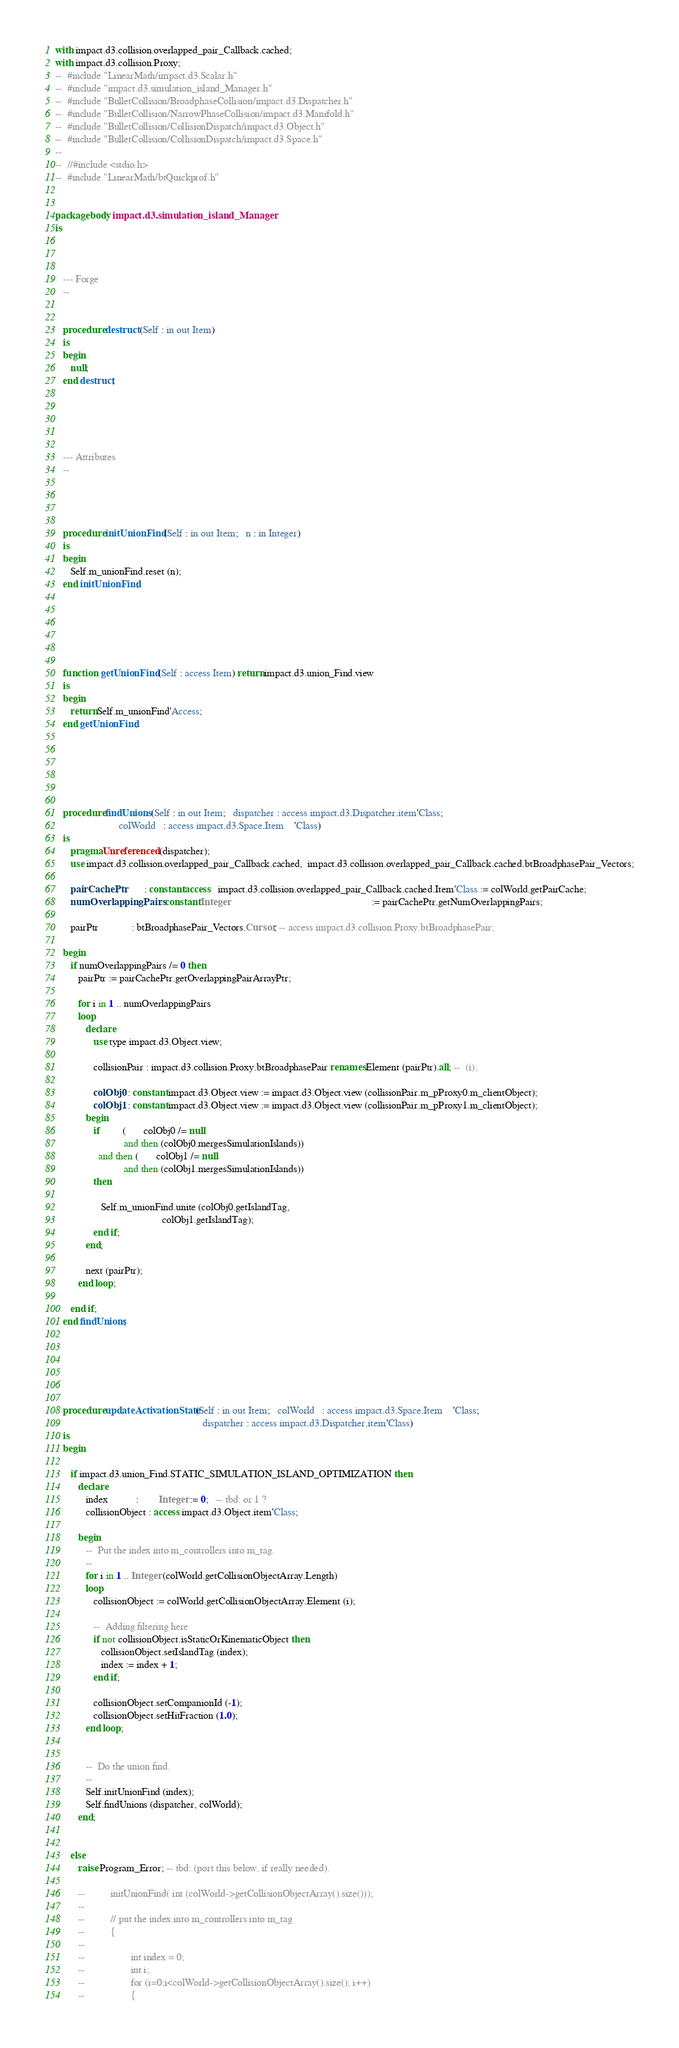Convert code to text. <code><loc_0><loc_0><loc_500><loc_500><_Ada_>with impact.d3.collision.overlapped_pair_Callback.cached;
with impact.d3.collision.Proxy;
--  #include "LinearMath/impact.d3.Scalar.h"
--  #include "impact.d3.simulation_island_Manager.h"
--  #include "BulletCollision/BroadphaseCollision/impact.d3.Dispatcher.h"
--  #include "BulletCollision/NarrowPhaseCollision/impact.d3.Manifold.h"
--  #include "BulletCollision/CollisionDispatch/impact.d3.Object.h"
--  #include "BulletCollision/CollisionDispatch/impact.d3.Space.h"
--
--  //#include <stdio.h>
--  #include "LinearMath/btQuickprof.h"


package body impact.d3.simulation_island_Manager
is



   --- Forge
   --


   procedure destruct (Self : in out Item)
   is
   begin
      null;
   end destruct;





   --- Attributes
   --




   procedure initUnionFind (Self : in out Item;   n : in Integer)
   is
   begin
      Self.m_unionFind.reset (n);
   end initUnionFind;






   function  getUnionFind (Self : access Item) return impact.d3.union_Find.view
   is
   begin
      return Self.m_unionFind'Access;
   end getUnionFind;






   procedure findUnions (Self : in out Item;   dispatcher : access impact.d3.Dispatcher.item'Class;
                         colWorld   : access impact.d3.Space.Item    'Class)
   is
      pragma Unreferenced (dispatcher);
      use impact.d3.collision.overlapped_pair_Callback.cached,  impact.d3.collision.overlapped_pair_Callback.cached.btBroadphasePair_Vectors;

      pairCachePtr        : constant access   impact.d3.collision.overlapped_pair_Callback.cached.Item'Class := colWorld.getPairCache;
      numOverlappingPairs : constant Integer                                                        := pairCachePtr.getNumOverlappingPairs;

      pairPtr             : btBroadphasePair_Vectors.Cursor; -- access impact.d3.collision.Proxy.btBroadphasePair;

   begin
      if numOverlappingPairs /= 0 then
         pairPtr := pairCachePtr.getOverlappingPairArrayPtr;

         for i in 1 .. numOverlappingPairs
         loop
            declare
               use type impact.d3.Object.view;

               collisionPair : impact.d3.collision.Proxy.btBroadphasePair renames Element (pairPtr).all; --  (i);

               colObj0 : constant impact.d3.Object.view := impact.d3.Object.view (collisionPair.m_pProxy0.m_clientObject);
               colObj1 : constant impact.d3.Object.view := impact.d3.Object.view (collisionPair.m_pProxy1.m_clientObject);
            begin
               if         (       colObj0 /= null
                           and then (colObj0.mergesSimulationIslands))
                 and then (       colObj1 /= null
                           and then (colObj1.mergesSimulationIslands))
               then

                  Self.m_unionFind.unite (colObj0.getIslandTag,
                                          colObj1.getIslandTag);
               end if;
            end;

            next (pairPtr);
         end loop;

      end if;
   end findUnions;






   procedure updateActivationState (Self : in out Item;   colWorld   : access impact.d3.Space.Item    'Class;
                                                          dispatcher : access impact.d3.Dispatcher.item'Class)
   is
   begin

      if impact.d3.union_Find.STATIC_SIMULATION_ISLAND_OPTIMIZATION then
         declare
            index           :        Integer := 0;   -- tbd: or 1 ?
            collisionObject : access impact.d3.Object.item'Class;

         begin
            --  Put the index into m_controllers into m_tag.
            --
            for i in 1 .. Integer (colWorld.getCollisionObjectArray.Length)
            loop
               collisionObject := colWorld.getCollisionObjectArray.Element (i);

               --  Adding filtering here
               if not collisionObject.isStaticOrKinematicObject then
                  collisionObject.setIslandTag (index);
                  index := index + 1;
               end if;

               collisionObject.setCompanionId (-1);
               collisionObject.setHitFraction (1.0);
            end loop;


            --  Do the union find.
            --
            Self.initUnionFind (index);
            Self.findUnions (dispatcher, colWorld);
         end;


      else
         raise Program_Error; -- tbd: (port this below, if really needed).

         --          initUnionFind( int (colWorld->getCollisionObjectArray().size()));
         --
         --          // put the index into m_controllers into m_tag
         --          {
         --
         --                  int index = 0;
         --                  int i;
         --                  for (i=0;i<colWorld->getCollisionObjectArray().size(); i++)
         --                  {</code> 